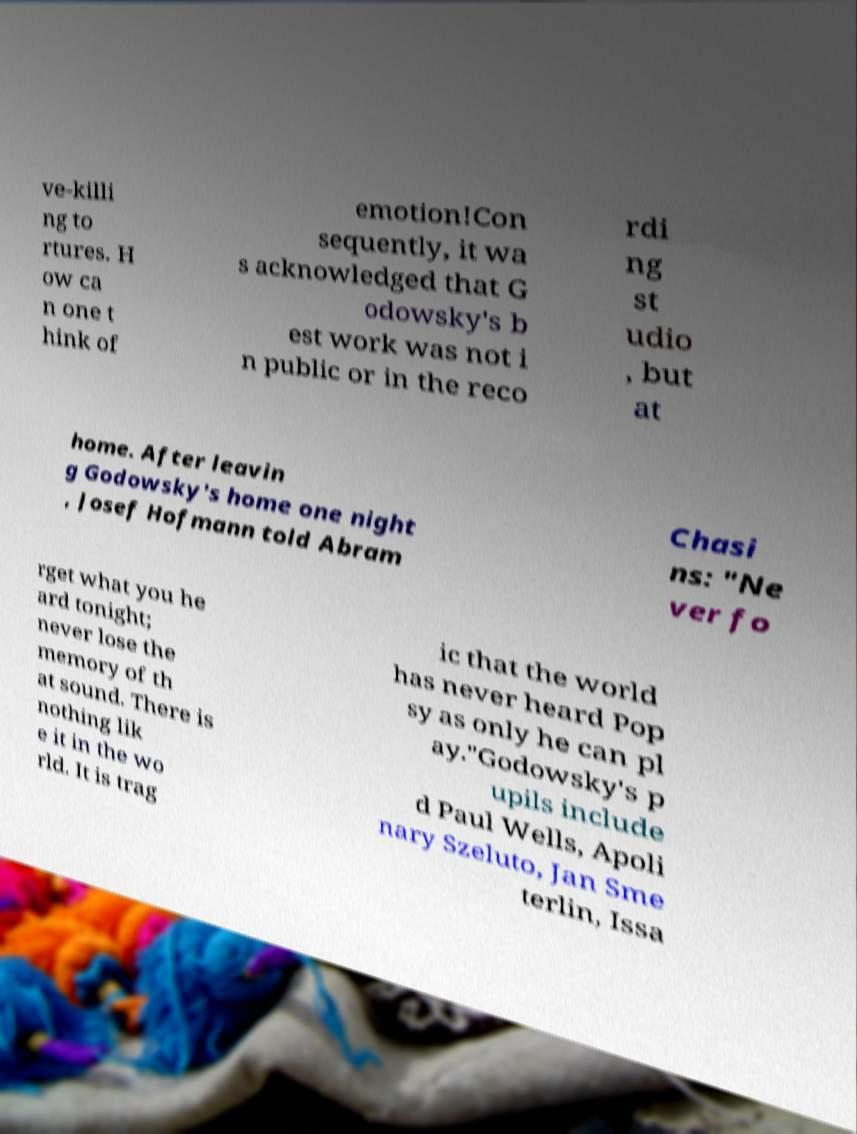Please read and relay the text visible in this image. What does it say? ve-killi ng to rtures. H ow ca n one t hink of emotion!Con sequently, it wa s acknowledged that G odowsky's b est work was not i n public or in the reco rdi ng st udio , but at home. After leavin g Godowsky's home one night , Josef Hofmann told Abram Chasi ns: "Ne ver fo rget what you he ard tonight; never lose the memory of th at sound. There is nothing lik e it in the wo rld. It is trag ic that the world has never heard Pop sy as only he can pl ay."Godowsky's p upils include d Paul Wells, Apoli nary Szeluto, Jan Sme terlin, Issa 